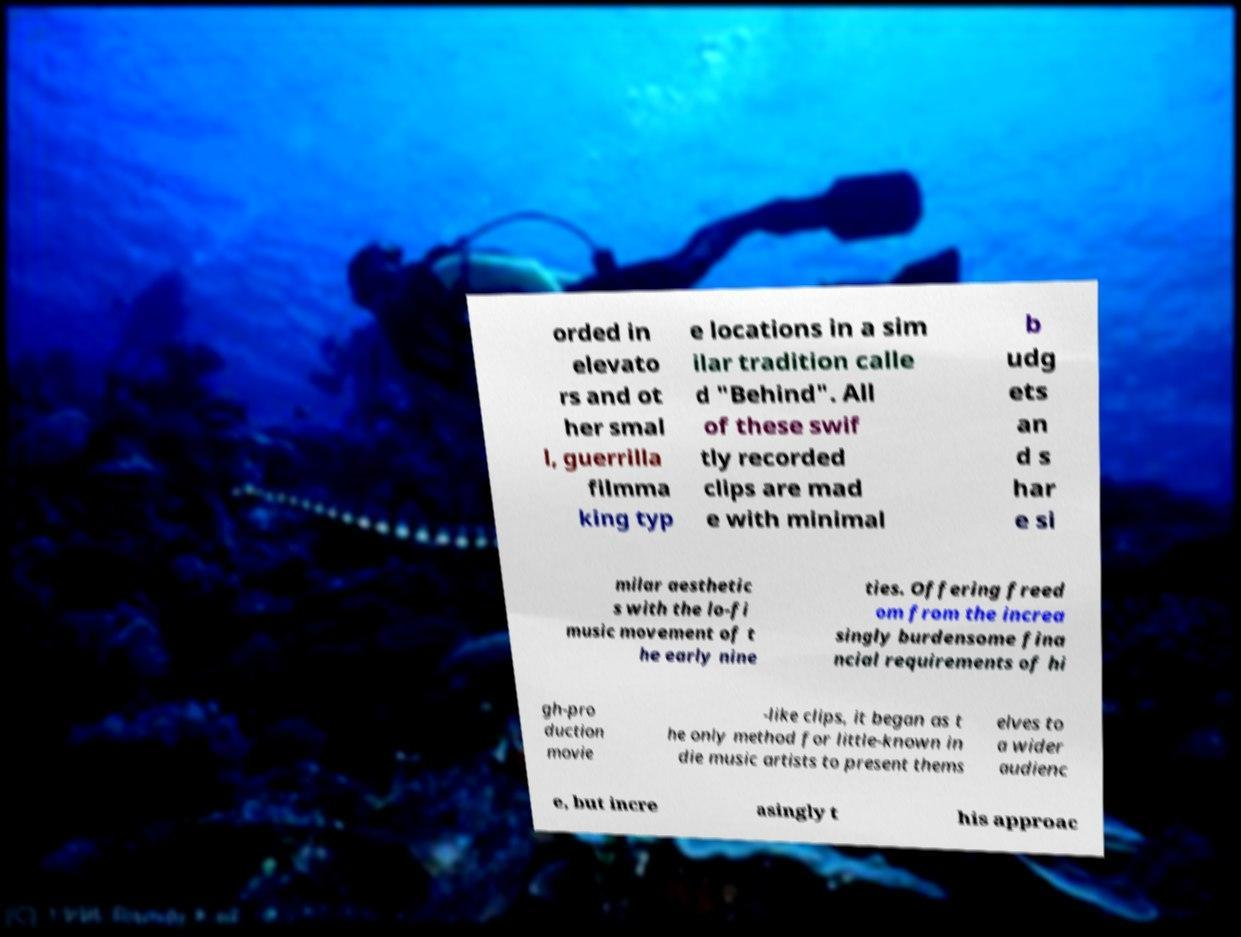Can you accurately transcribe the text from the provided image for me? orded in elevato rs and ot her smal l, guerrilla filmma king typ e locations in a sim ilar tradition calle d "Behind". All of these swif tly recorded clips are mad e with minimal b udg ets an d s har e si milar aesthetic s with the lo-fi music movement of t he early nine ties. Offering freed om from the increa singly burdensome fina ncial requirements of hi gh-pro duction movie -like clips, it began as t he only method for little-known in die music artists to present thems elves to a wider audienc e, but incre asingly t his approac 